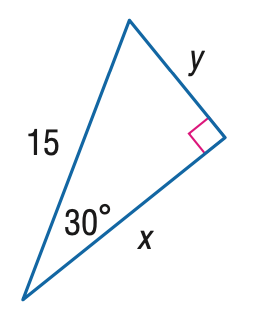Answer the mathemtical geometry problem and directly provide the correct option letter.
Question: Find y.
Choices: A: \frac { 15 } { 2 } B: \frac { 15 } { 2 } \sqrt { 2 } C: \frac { 15 } { 2 } \sqrt { 3 } D: 15 A 